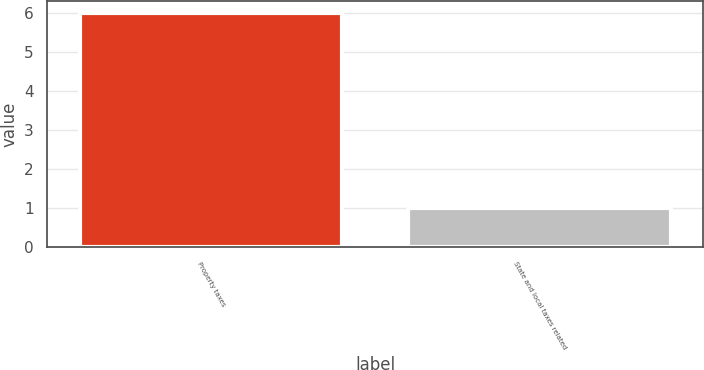Convert chart. <chart><loc_0><loc_0><loc_500><loc_500><bar_chart><fcel>Property taxes<fcel>State and local taxes related<nl><fcel>6<fcel>1<nl></chart> 